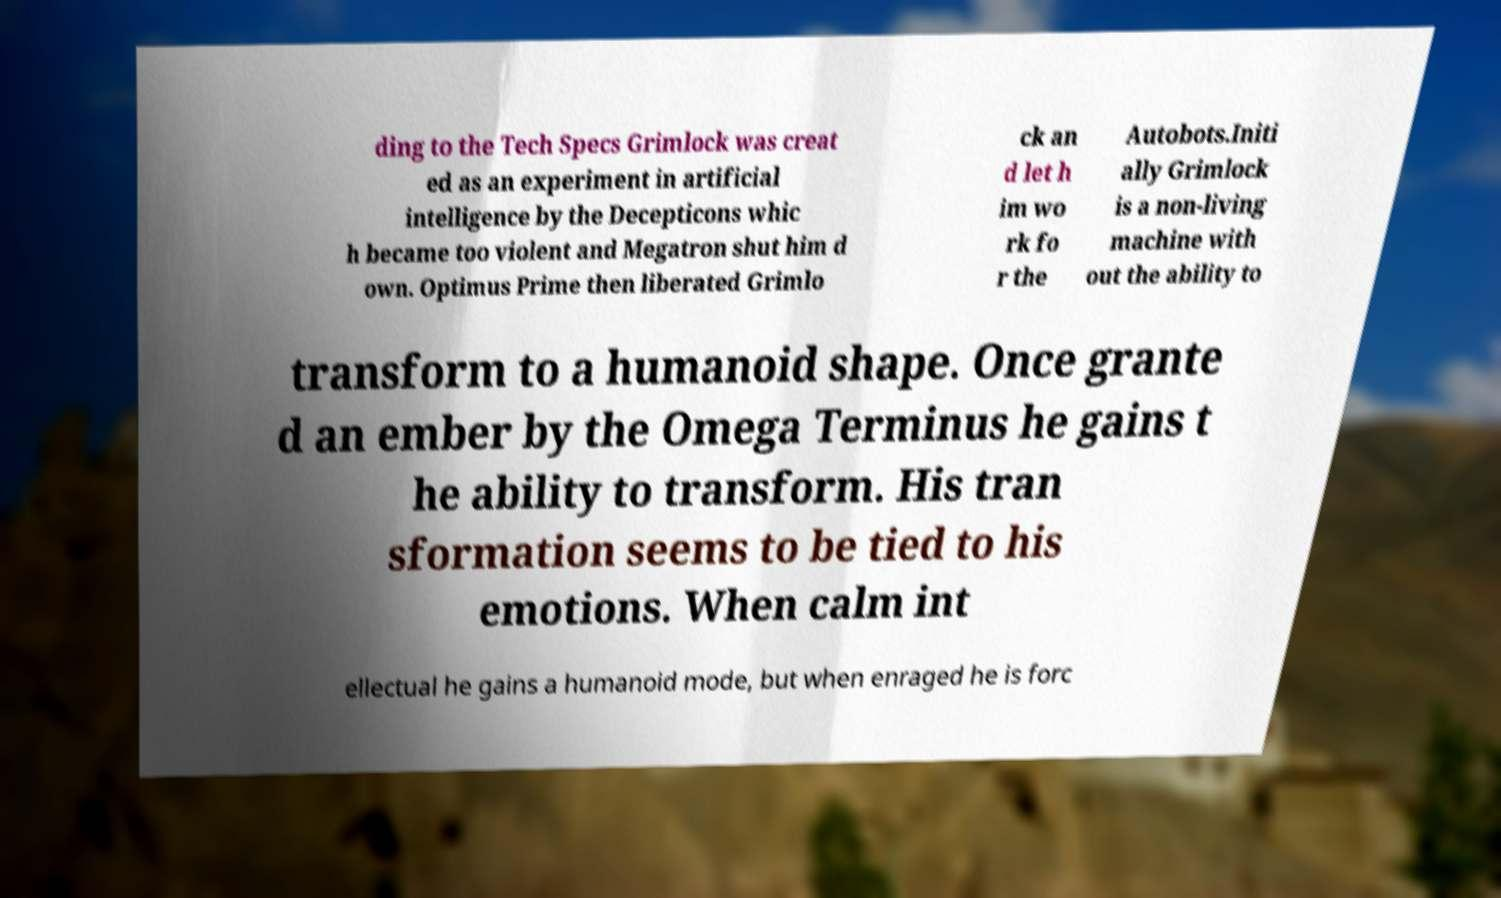Can you read and provide the text displayed in the image?This photo seems to have some interesting text. Can you extract and type it out for me? ding to the Tech Specs Grimlock was creat ed as an experiment in artificial intelligence by the Decepticons whic h became too violent and Megatron shut him d own. Optimus Prime then liberated Grimlo ck an d let h im wo rk fo r the Autobots.Initi ally Grimlock is a non-living machine with out the ability to transform to a humanoid shape. Once grante d an ember by the Omega Terminus he gains t he ability to transform. His tran sformation seems to be tied to his emotions. When calm int ellectual he gains a humanoid mode, but when enraged he is forc 